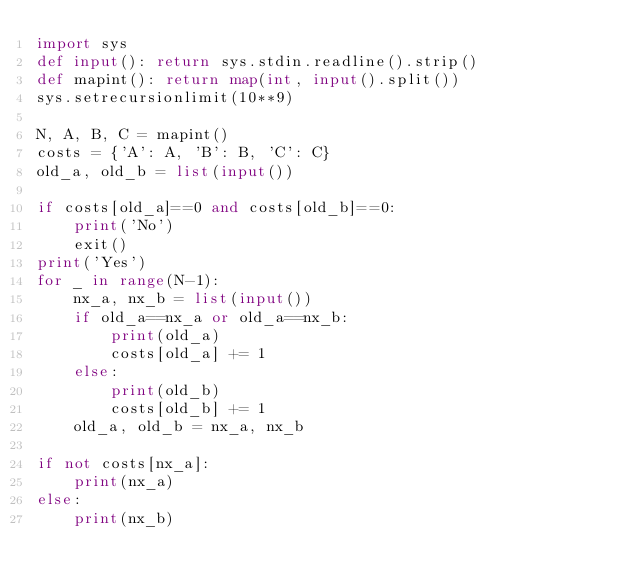Convert code to text. <code><loc_0><loc_0><loc_500><loc_500><_Python_>import sys
def input(): return sys.stdin.readline().strip()
def mapint(): return map(int, input().split())
sys.setrecursionlimit(10**9)

N, A, B, C = mapint()
costs = {'A': A, 'B': B, 'C': C}
old_a, old_b = list(input())

if costs[old_a]==0 and costs[old_b]==0:
    print('No')
    exit()
print('Yes')
for _ in range(N-1):
    nx_a, nx_b = list(input())
    if old_a==nx_a or old_a==nx_b:
        print(old_a)
        costs[old_a] += 1
    else:
        print(old_b)
        costs[old_b] += 1
    old_a, old_b = nx_a, nx_b

if not costs[nx_a]:
    print(nx_a)
else:
    print(nx_b)</code> 